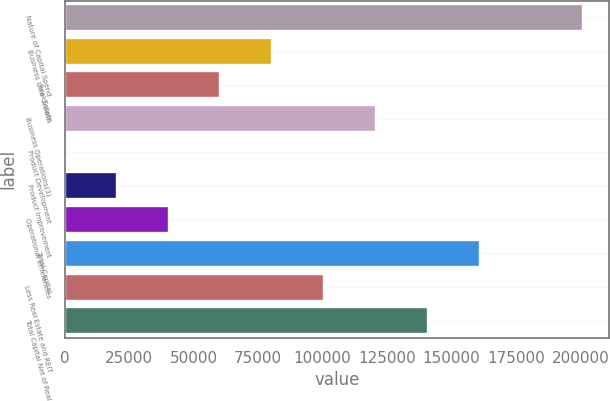<chart> <loc_0><loc_0><loc_500><loc_500><bar_chart><fcel>Nature of Capital Spend<fcel>Business Line Growth<fcel>Real Estate<fcel>Business Operations(3)<fcel>Product Development<fcel>Product Improvement<fcel>Operational Efficiencies<fcel>Total Capital<fcel>Less Real Estate and REIT<fcel>Total Capital Net of Real<nl><fcel>201212<fcel>80484.9<fcel>60363.7<fcel>120727<fcel>0.1<fcel>20121.3<fcel>40242.5<fcel>160970<fcel>100606<fcel>140848<nl></chart> 